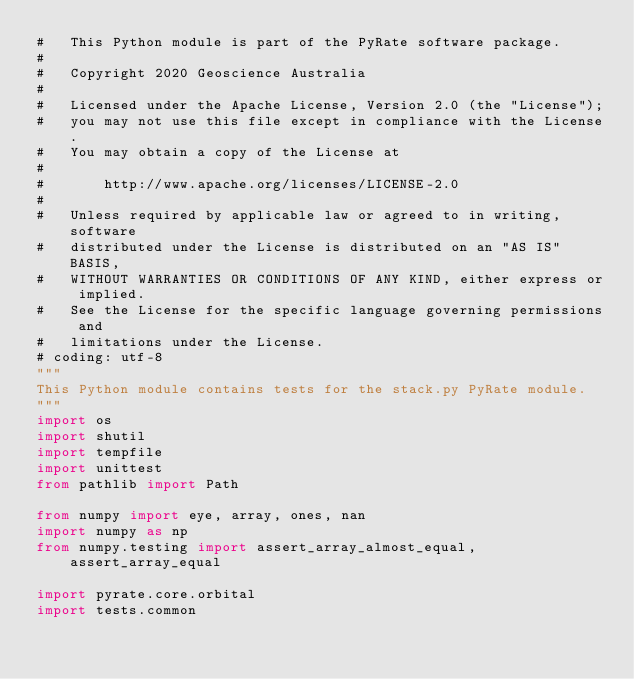Convert code to text. <code><loc_0><loc_0><loc_500><loc_500><_Python_>#   This Python module is part of the PyRate software package.
#
#   Copyright 2020 Geoscience Australia
#
#   Licensed under the Apache License, Version 2.0 (the "License");
#   you may not use this file except in compliance with the License.
#   You may obtain a copy of the License at
#
#       http://www.apache.org/licenses/LICENSE-2.0
#
#   Unless required by applicable law or agreed to in writing, software
#   distributed under the License is distributed on an "AS IS" BASIS,
#   WITHOUT WARRANTIES OR CONDITIONS OF ANY KIND, either express or implied.
#   See the License for the specific language governing permissions and
#   limitations under the License.
# coding: utf-8
"""
This Python module contains tests for the stack.py PyRate module.
"""
import os
import shutil
import tempfile
import unittest
from pathlib import Path

from numpy import eye, array, ones, nan
import numpy as np
from numpy.testing import assert_array_almost_equal, assert_array_equal

import pyrate.core.orbital
import tests.common</code> 